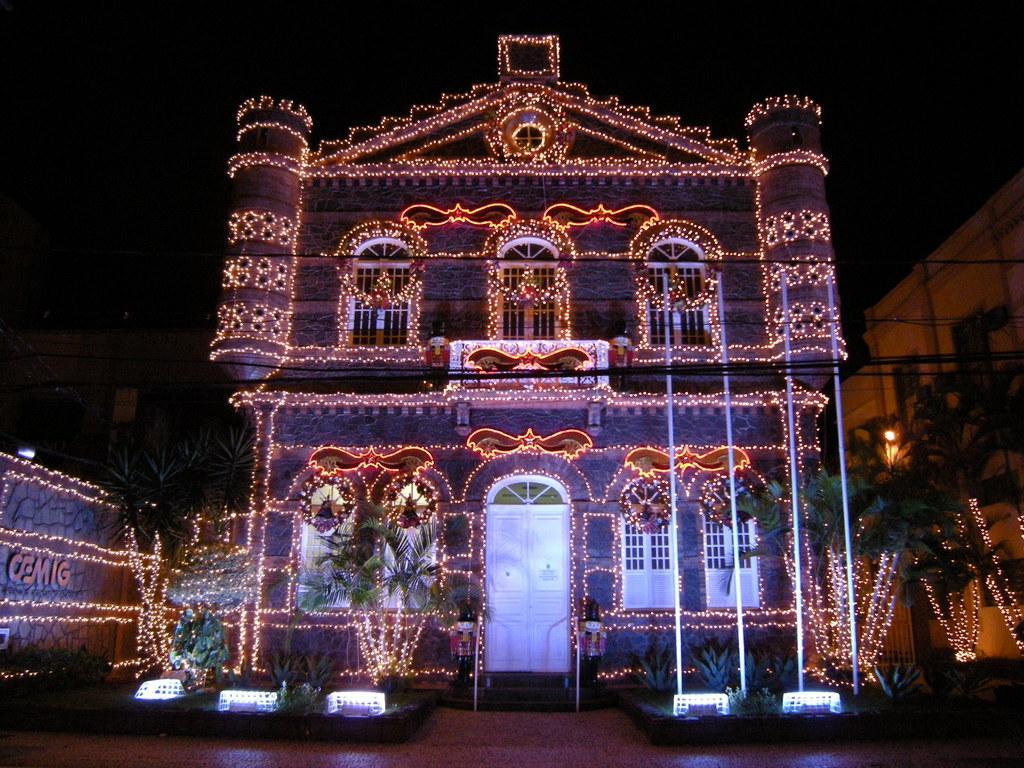Describe this image in one or two sentences. This picture is clicked outside. In the foreground we can see the green leaves, plants and we can see the buildings and the decoration lights. In the background we can see the sky and some other items. 